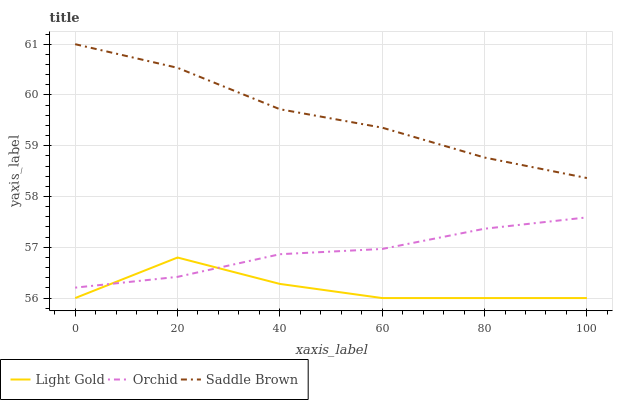Does Orchid have the minimum area under the curve?
Answer yes or no. No. Does Orchid have the maximum area under the curve?
Answer yes or no. No. Is Saddle Brown the smoothest?
Answer yes or no. No. Is Saddle Brown the roughest?
Answer yes or no. No. Does Orchid have the lowest value?
Answer yes or no. No. Does Orchid have the highest value?
Answer yes or no. No. Is Light Gold less than Saddle Brown?
Answer yes or no. Yes. Is Saddle Brown greater than Orchid?
Answer yes or no. Yes. Does Light Gold intersect Saddle Brown?
Answer yes or no. No. 